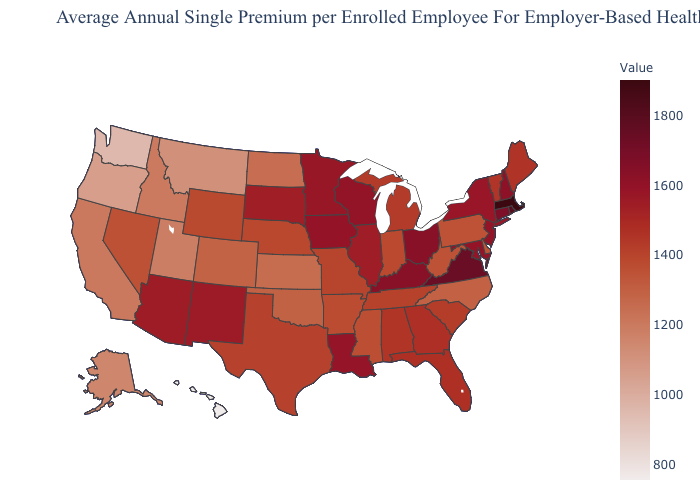Which states have the highest value in the USA?
Give a very brief answer. Massachusetts. Does Michigan have the highest value in the MidWest?
Short answer required. No. Does Florida have the lowest value in the USA?
Concise answer only. No. Does New York have the highest value in the Northeast?
Be succinct. No. Does North Dakota have a higher value than Illinois?
Short answer required. No. Does Iowa have the highest value in the USA?
Be succinct. No. Which states hav the highest value in the West?
Quick response, please. New Mexico. 